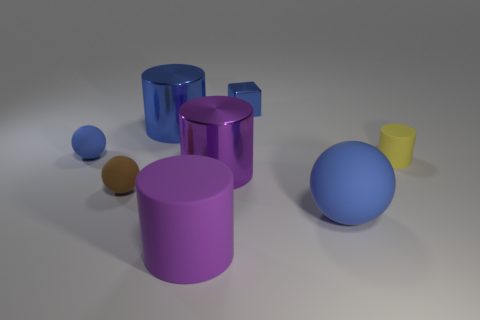Add 1 blue things. How many objects exist? 9 Subtract all blocks. How many objects are left? 7 Subtract all big objects. Subtract all big matte things. How many objects are left? 2 Add 5 yellow rubber things. How many yellow rubber things are left? 6 Add 2 tiny objects. How many tiny objects exist? 6 Subtract 0 cyan spheres. How many objects are left? 8 